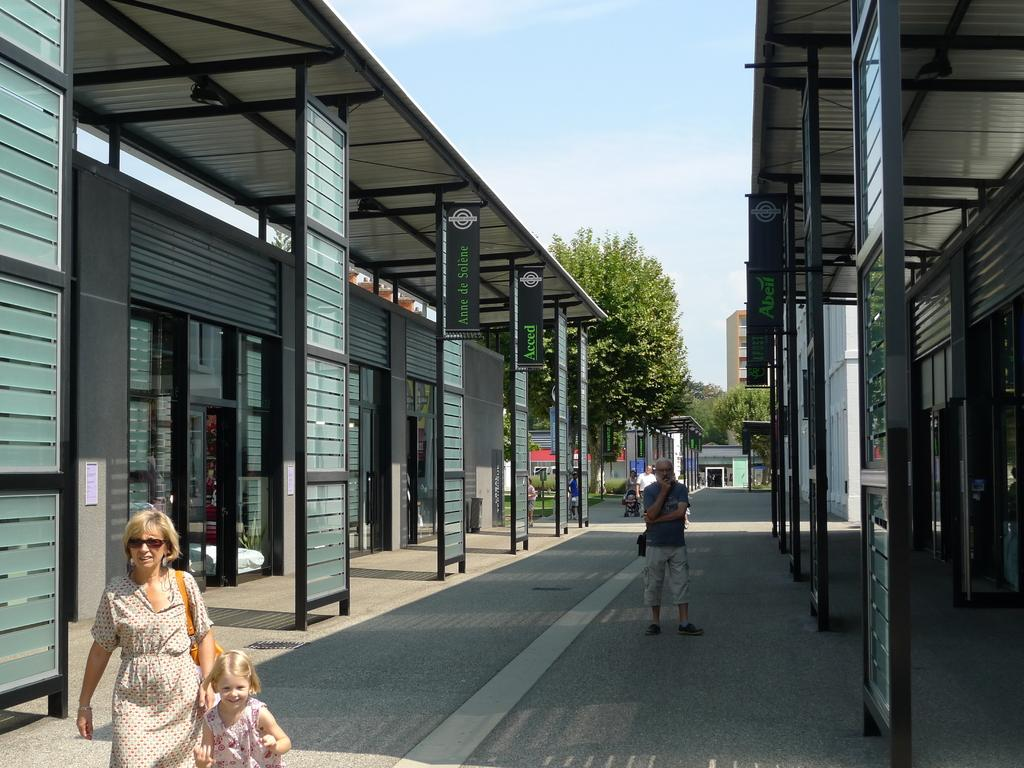What is happening on the road in the image? There are persons on the road in the image. What type of structure can be seen in the image? There is a shed in the image. What type of establishments are present in the image? There are stores in the image. What can be used to provide information to people in the image? Information boards are present in the image. What can be used to identify specific locations or individuals in the image? Name plates are visible in the image. What type of natural element is present in the image? There are trees in the image. What part of the natural environment is visible in the image? The sky is visible in the image. What type of comfort can be seen in the image? There is no specific comfort item present in the image. What type of window can be seen in the image? There is no window present in the image. 